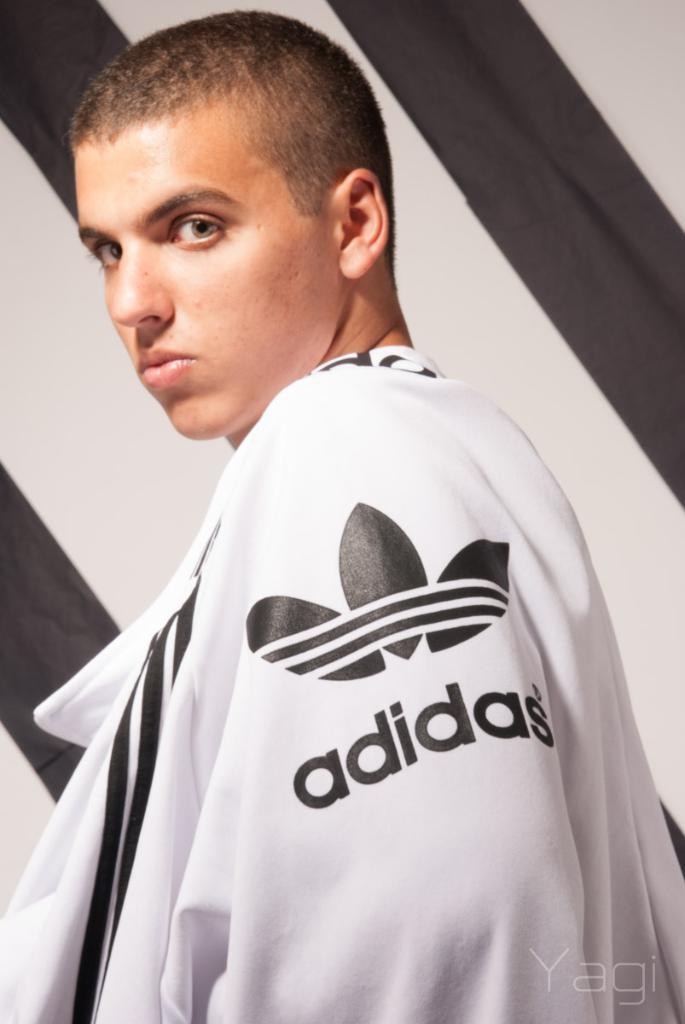Provide a one-sentence caption for the provided image. Boy wearing a white sweater that says Adidas. 